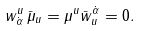Convert formula to latex. <formula><loc_0><loc_0><loc_500><loc_500>w _ { \dot { \alpha } } ^ { u } \, \bar { \mu } _ { u } = \mu ^ { u } \bar { w } ^ { \dot { \alpha } } _ { u } = 0 .</formula> 